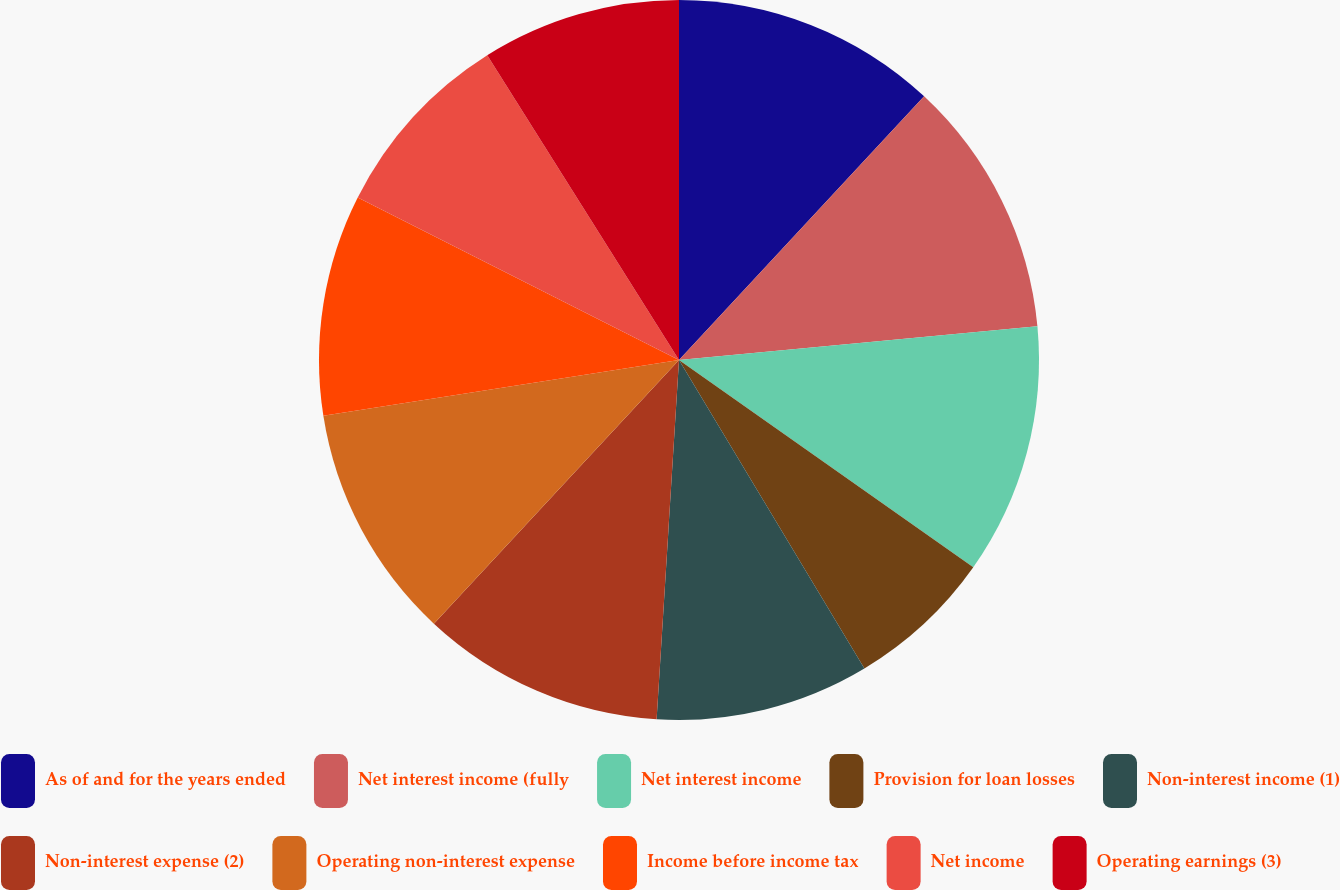Convert chart to OTSL. <chart><loc_0><loc_0><loc_500><loc_500><pie_chart><fcel>As of and for the years ended<fcel>Net interest income (fully<fcel>Net interest income<fcel>Provision for loan losses<fcel>Non-interest income (1)<fcel>Non-interest expense (2)<fcel>Operating non-interest expense<fcel>Income before income tax<fcel>Net income<fcel>Operating earnings (3)<nl><fcel>11.92%<fcel>11.59%<fcel>11.26%<fcel>6.62%<fcel>9.6%<fcel>10.93%<fcel>10.6%<fcel>9.93%<fcel>8.61%<fcel>8.94%<nl></chart> 